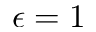<formula> <loc_0><loc_0><loc_500><loc_500>\epsilon = 1</formula> 